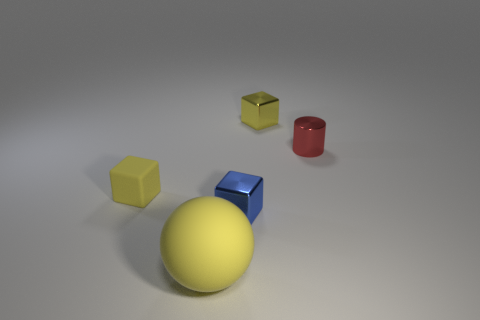Subtract all red spheres. How many yellow blocks are left? 2 Subtract 1 blocks. How many blocks are left? 2 Add 2 big yellow objects. How many objects exist? 7 Subtract all cylinders. How many objects are left? 4 Subtract 0 blue cylinders. How many objects are left? 5 Subtract all brown metallic balls. Subtract all yellow metal things. How many objects are left? 4 Add 5 tiny red shiny things. How many tiny red shiny things are left? 6 Add 2 yellow matte blocks. How many yellow matte blocks exist? 3 